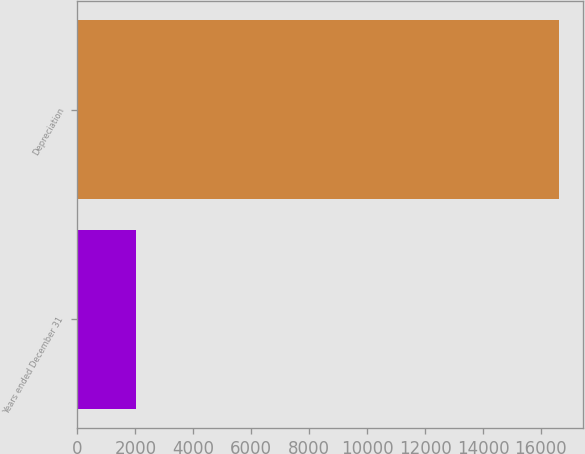<chart> <loc_0><loc_0><loc_500><loc_500><bar_chart><fcel>Years ended December 31<fcel>Depreciation<nl><fcel>2014<fcel>16627<nl></chart> 